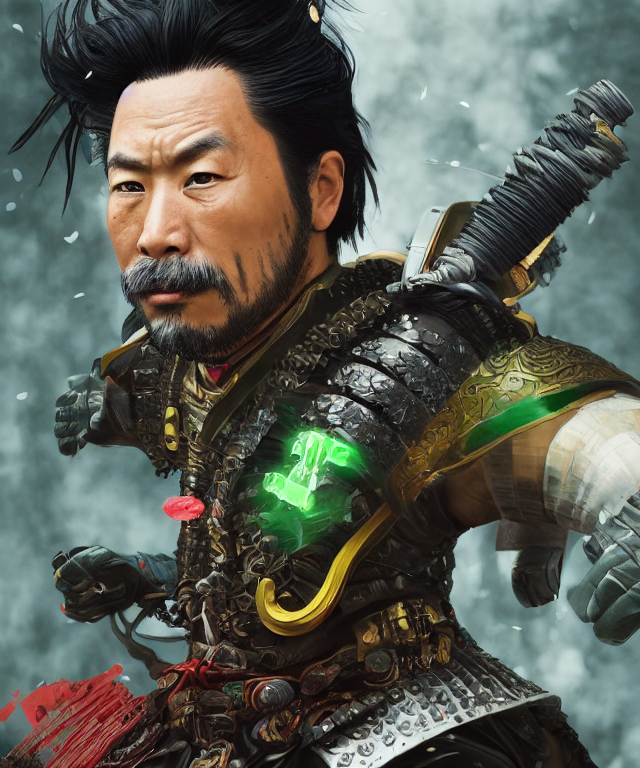Can you tell me more about the character's attire and its significance? Certainly, the character is dressed in ornate, traditional samurai armor, which may indicate a high rank or significant status. The intricate details and patterns suggest fine craftsmanship and the importance of honor and duty in the character's culture. The glowing green jewel has a supernatural aura, possibly signaling a special power or a key to unlocking hidden abilities. 